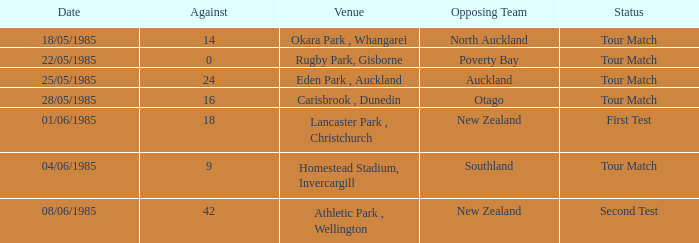Which opposing team had an Against score less than 42 and a Tour Match status in Rugby Park, Gisborne? Poverty Bay. Can you parse all the data within this table? {'header': ['Date', 'Against', 'Venue', 'Opposing Team', 'Status'], 'rows': [['18/05/1985', '14', 'Okara Park , Whangarei', 'North Auckland', 'Tour Match'], ['22/05/1985', '0', 'Rugby Park, Gisborne', 'Poverty Bay', 'Tour Match'], ['25/05/1985', '24', 'Eden Park , Auckland', 'Auckland', 'Tour Match'], ['28/05/1985', '16', 'Carisbrook , Dunedin', 'Otago', 'Tour Match'], ['01/06/1985', '18', 'Lancaster Park , Christchurch', 'New Zealand', 'First Test'], ['04/06/1985', '9', 'Homestead Stadium, Invercargill', 'Southland', 'Tour Match'], ['08/06/1985', '42', 'Athletic Park , Wellington', 'New Zealand', 'Second Test']]} 